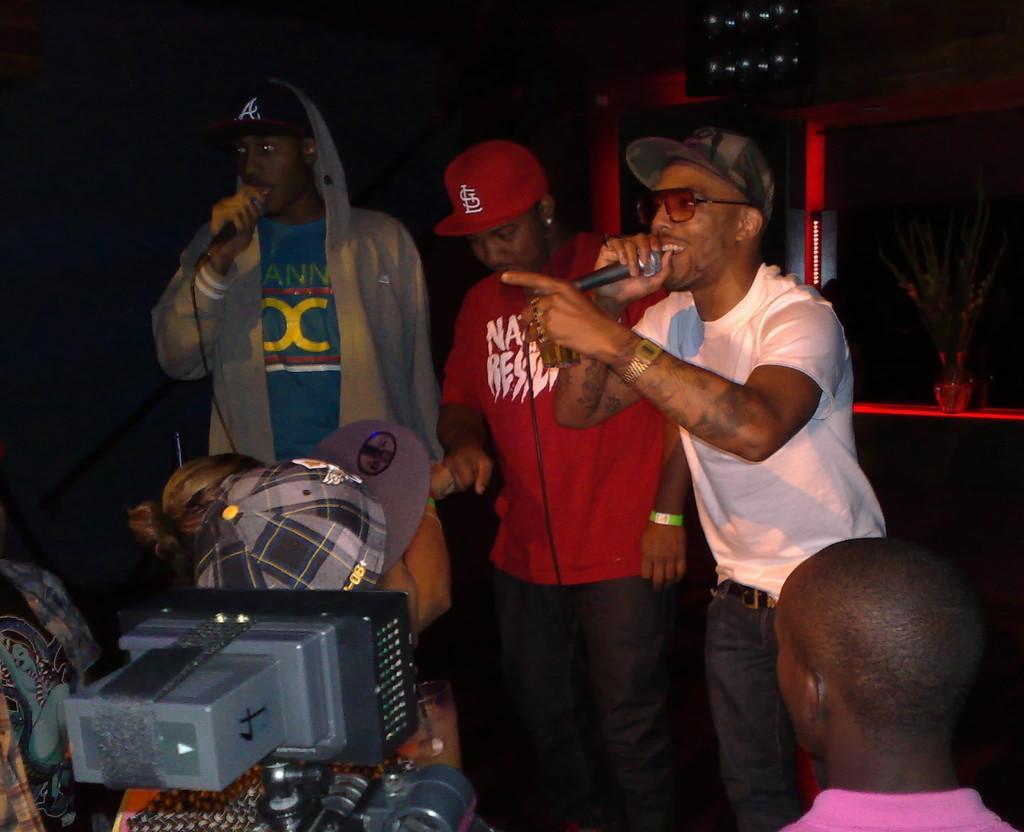Could you give a brief overview of what you see in this image? On the right side a man is singing in the microphone, he wore t-shirt,spectacles and cap. On the left side there is another man who is holding a microphone in his hand. 